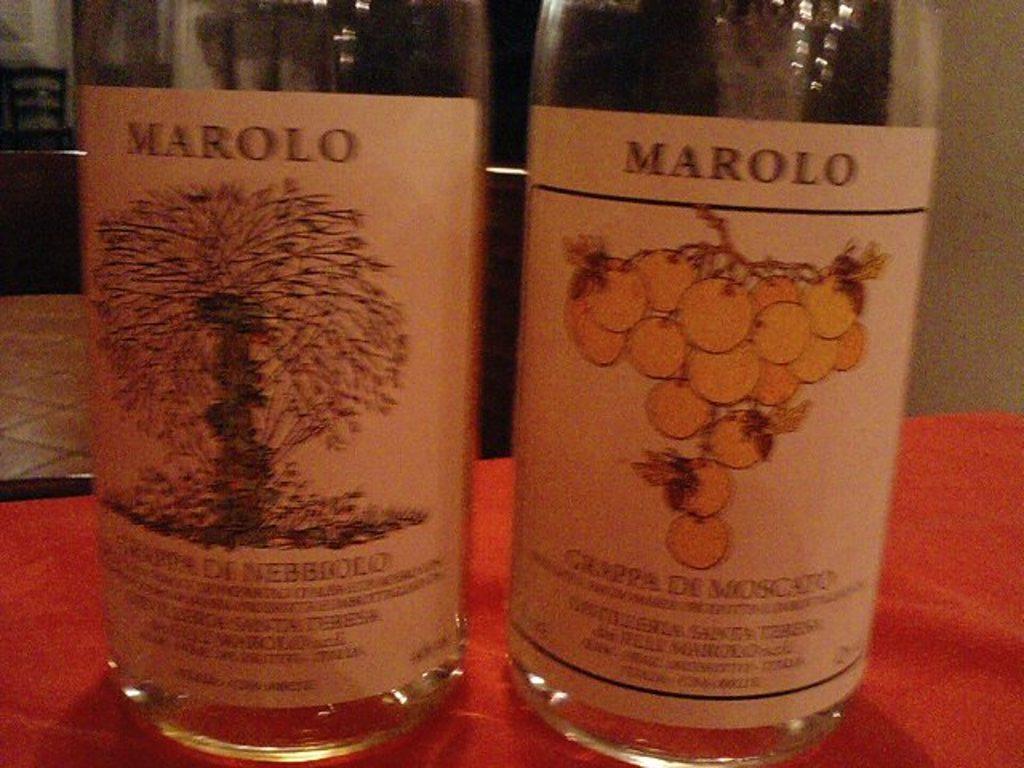What is the wine brand?
Give a very brief answer. Marolo. What kind of wine is in the right hand bottle?
Make the answer very short. Marolo. 